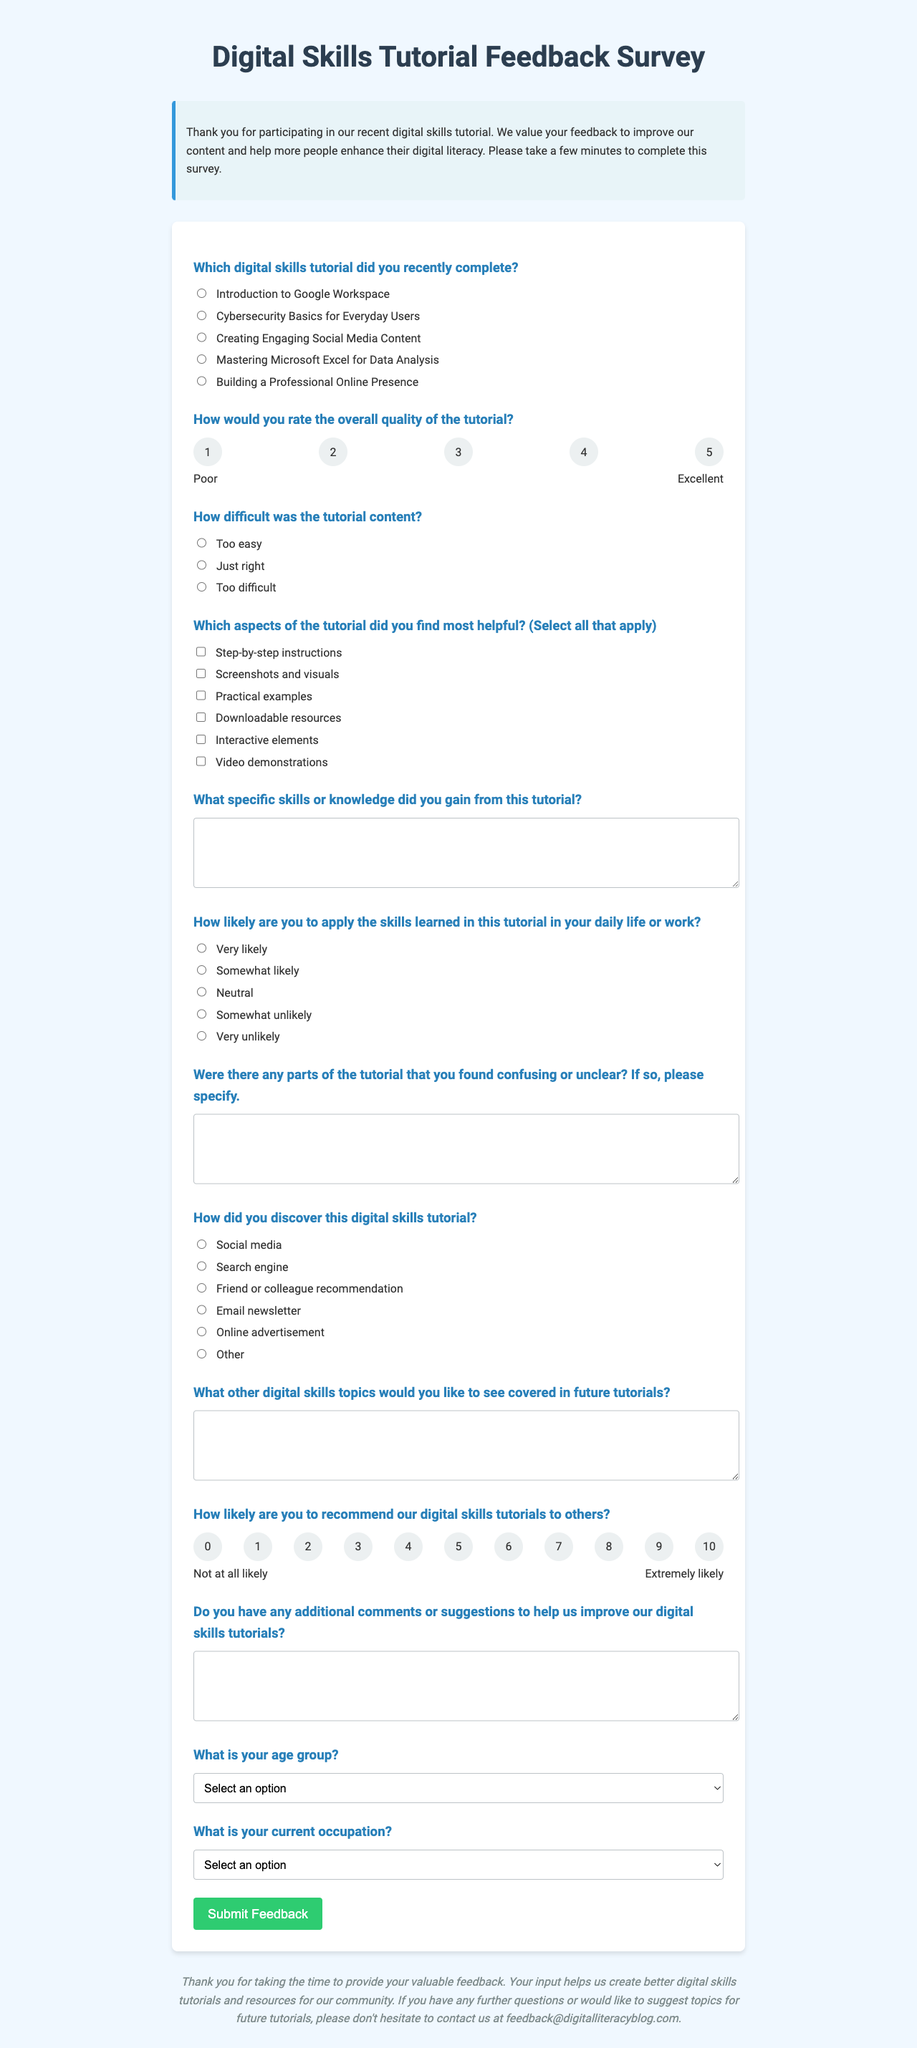What is the title of the form? The title of the form is displayed prominently at the top of the document.
Answer: Digital Skills Tutorial Feedback Survey What is the overall quality rating scale used in the tutorial? The scale for rating the overall quality of the tutorial is numbered from 1 to 5.
Answer: 1-5 Which aspect of the tutorial has the option "Video demonstrations"? This is one of the options provided for feedback on the helpful aspects of the tutorial.
Answer: Checkbox options How did participants find the content difficulty? The document provides options for participants to choose the level of difficulty they encountered.
Answer: Too easy, Just right, Too difficult What email address can participants use for further questions or suggestions? The document provides a specific email address for follow-up communication related to the feedback.
Answer: feedback@digitalliteracyblog.com What age group option includes individuals who are 35 years old? The document includes age group options for participants to select from.
Answer: 35-44 